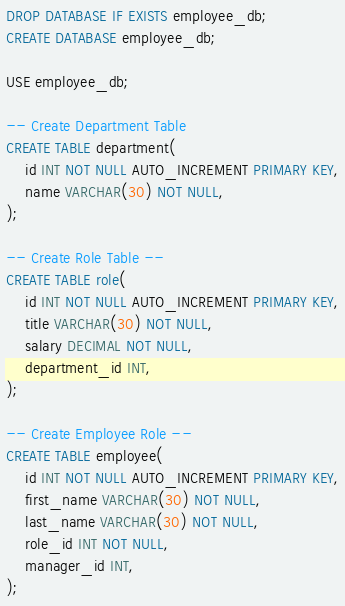<code> <loc_0><loc_0><loc_500><loc_500><_SQL_>DROP DATABASE IF EXISTS employee_db;
CREATE DATABASE employee_db;

USE employee_db;

-- Create Department Table
CREATE TABLE department(
    id INT NOT NULL AUTO_INCREMENT PRIMARY KEY,
    name VARCHAR(30) NOT NULL,
);

-- Create Role Table --
CREATE TABLE role(
    id INT NOT NULL AUTO_INCREMENT PRIMARY KEY,
    title VARCHAR(30) NOT NULL,
    salary DECIMAL NOT NULL,
    department_id INT,
);

-- Create Employee Role --
CREATE TABLE employee(
    id INT NOT NULL AUTO_INCREMENT PRIMARY KEY,
    first_name VARCHAR(30) NOT NULL,
    last_name VARCHAR(30) NOT NULL,
    role_id INT NOT NULL,
    manager_id INT,
);</code> 